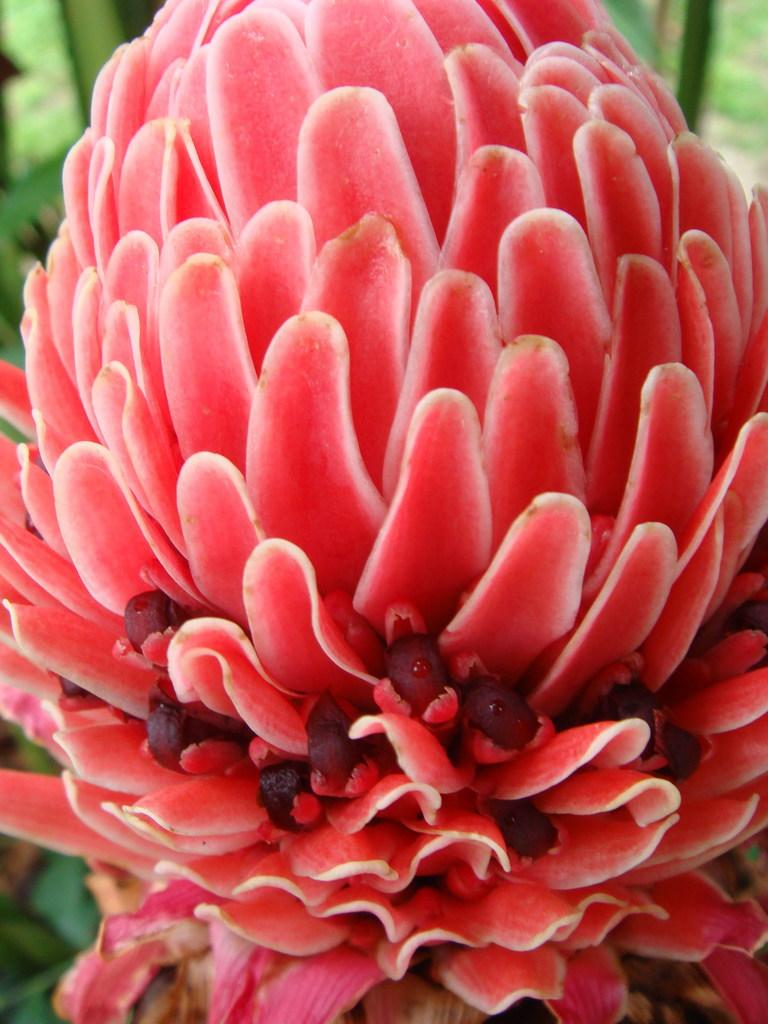What is the main subject of the image? There is a flower in the image. What color are the petals of the flower? The petals of the flower are red. What else can be seen in the background of the image? There are leaves visible in the background of the image. What country is the flower from in the image? The image does not provide information about the country of origin for the flower. Can you recall any memories associated with the flower in the image? The image does not provide any information about personal memories related to the flower. 